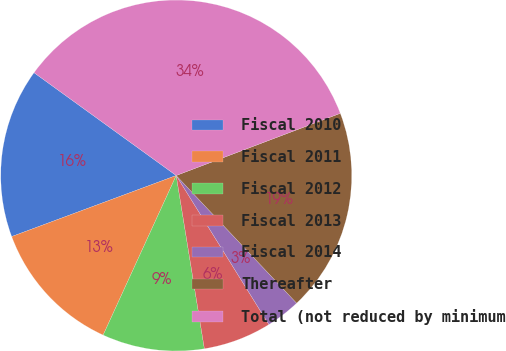<chart> <loc_0><loc_0><loc_500><loc_500><pie_chart><fcel>Fiscal 2010<fcel>Fiscal 2011<fcel>Fiscal 2012<fcel>Fiscal 2013<fcel>Fiscal 2014<fcel>Thereafter<fcel>Total (not reduced by minimum<nl><fcel>15.62%<fcel>12.51%<fcel>9.4%<fcel>6.29%<fcel>3.18%<fcel>18.73%<fcel>34.27%<nl></chart> 